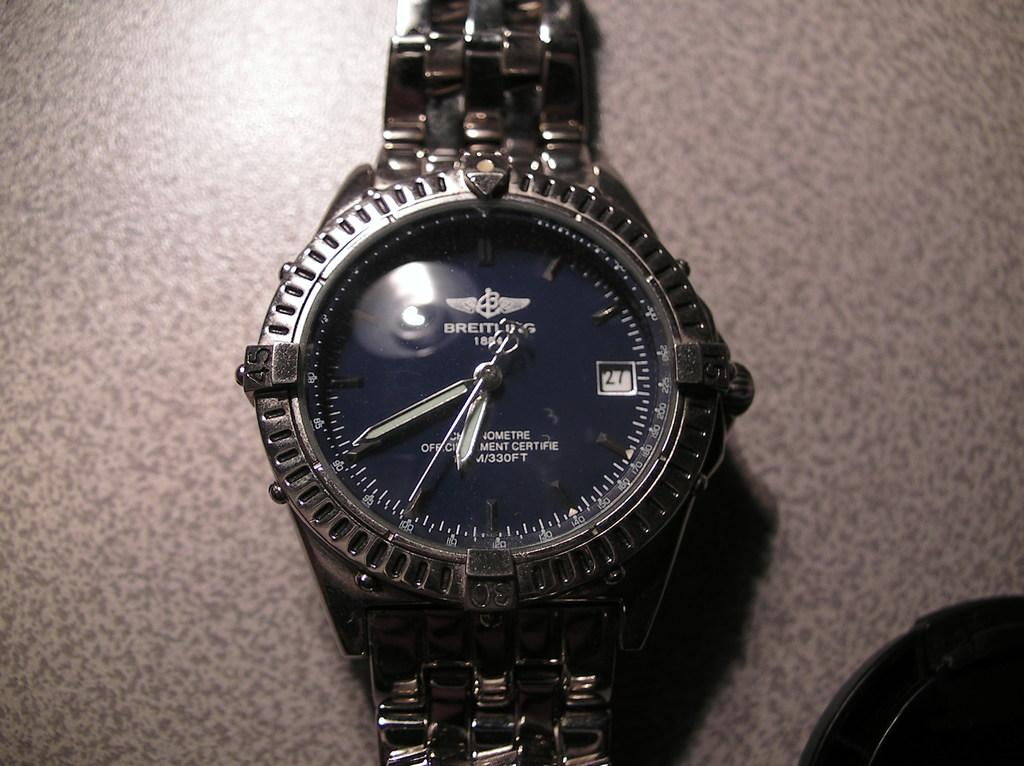<image>
Give a short and clear explanation of the subsequent image. The Breathing watch design has a very sophisticated look to it. 